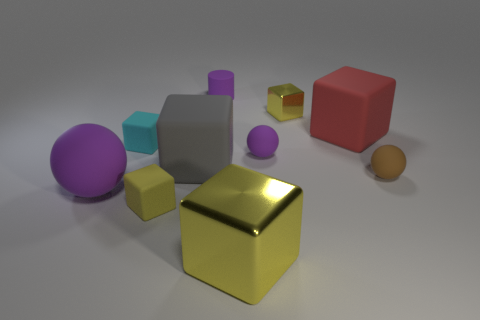What color is the large rubber object right of the shiny object behind the small sphere right of the big red block?
Ensure brevity in your answer.  Red. What number of objects are either brown matte spheres or things?
Offer a very short reply. 10. How many large yellow metallic objects have the same shape as the big red object?
Provide a short and direct response. 1. Do the tiny purple cylinder and the tiny yellow object that is on the left side of the purple rubber cylinder have the same material?
Provide a short and direct response. Yes. What is the size of the gray thing that is the same material as the cylinder?
Offer a terse response. Large. There is a purple rubber object left of the purple cylinder; how big is it?
Your answer should be very brief. Large. What number of purple things have the same size as the cyan rubber object?
Make the answer very short. 2. What is the size of the metal block that is the same color as the small shiny object?
Ensure brevity in your answer.  Large. Are there any large matte cubes that have the same color as the big rubber sphere?
Offer a terse response. No. What is the color of the matte ball that is the same size as the gray object?
Ensure brevity in your answer.  Purple. 